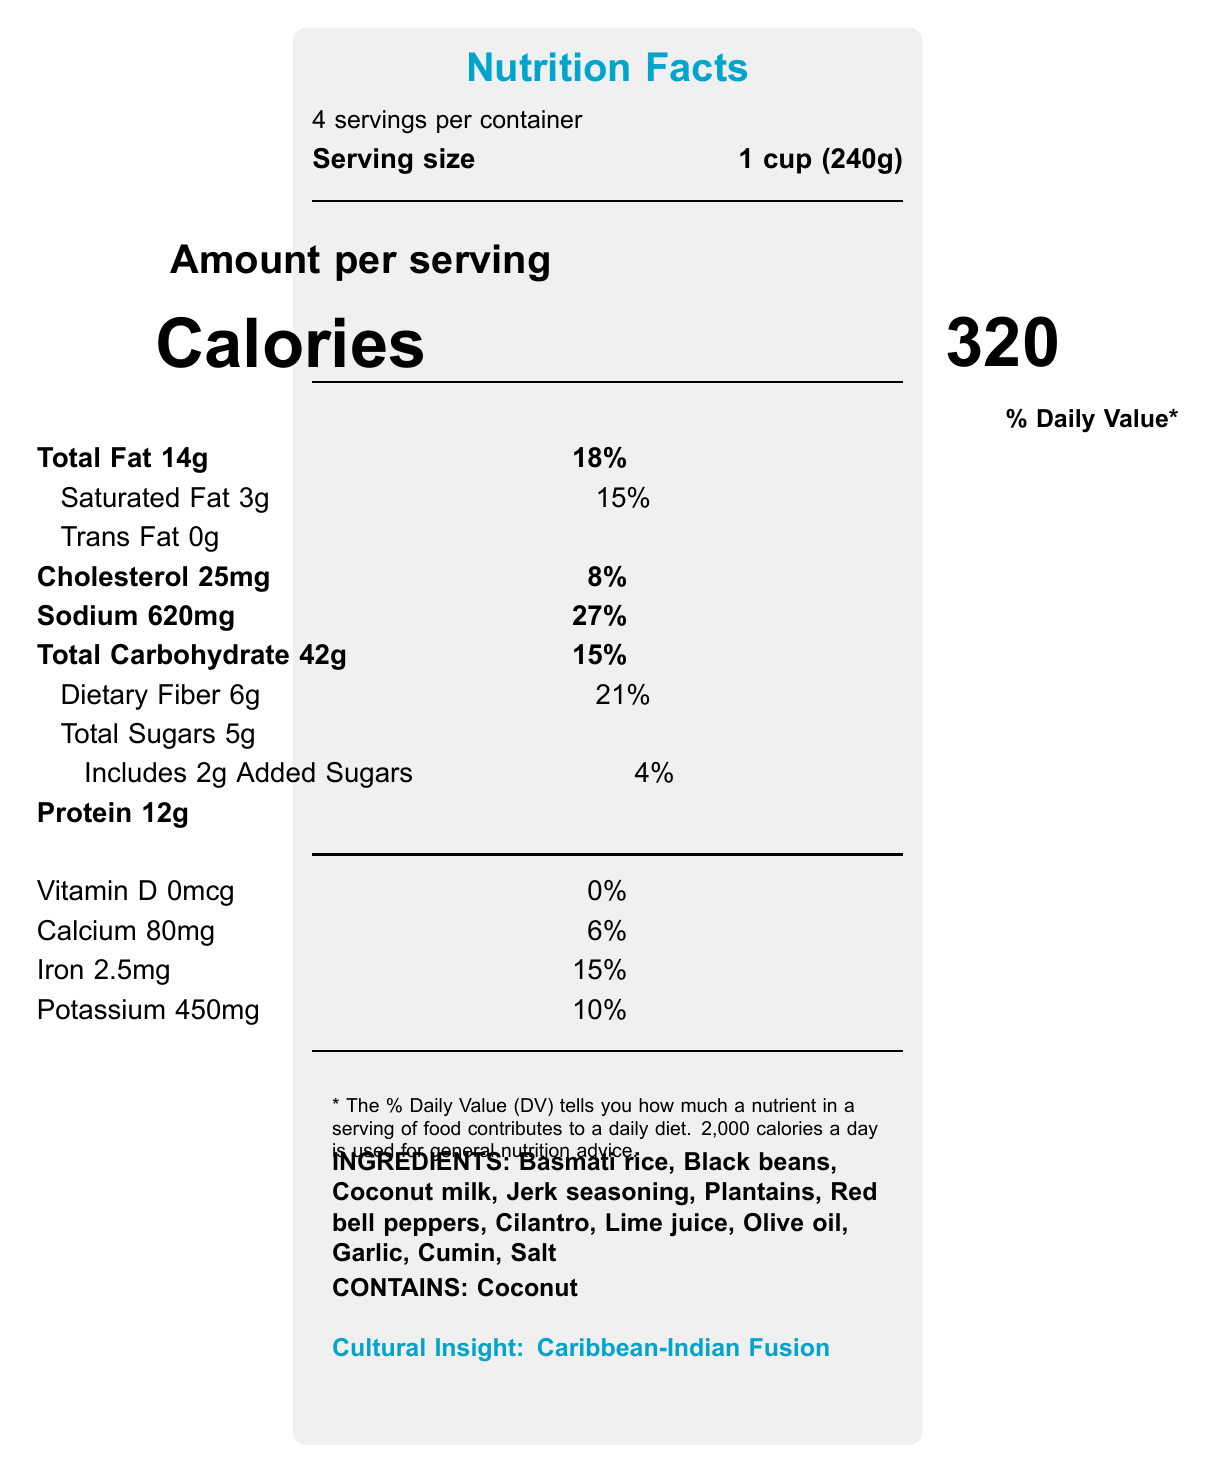What is the serving size? The serving size is clearly stated at the beginning of the document.
Answer: 1 cup (240g) How many servings are there per container? The document states there are 4 servings per container.
Answer: 4 What is the calories per serving? The document shows that each serving contains 320 calories.
Answer: 320 How much total fat is in one serving? The total fat content per serving is listed as 14g.
Answer: 14g What percentage of the daily value of sodium does one serving provide? The document lists that one serving contains 27% of the daily value for sodium.
Answer: 27% Which ingredient in the dish represents Indian influence? According to the cultural insights, basmati rice is indicative of Indian influence.
Answer: Basmati rice Which of the following is an allergen in this dish? A. Milk B. Coconut C. Soy The document lists coconut as an allergen.
Answer: B. Coconut What does the dietary fiber content per serving support? A. Heart health B. Digestive health C. Bone health The nutritional highlights mention that the high fiber content from beans and plantains supports digestive health.
Answer: B. Digestive health Is the protein source plant-based? The document notes that the protein source, black beans, is plant-based.
Answer: Yes Describe the main idea of the document. The document contains various elements that collectively describe the nutritional content, cultural symbolism, and individual identity aspects of the dish.
Answer: The document is a Nutrition Facts Label for a fusion cuisine dish that blends elements of Caribbean and Indian cultures. It provides nutritional information, lists ingredients and allergens, and offers cultural and identity insights related to diaspora communities. What is the exact amount of Vitamin D present in a serving? The document lists the Vitamin D content per serving as 0mcg.
Answer: 0mcg Based on the document, can we determine the cooking method used for this dish? The document provides nutritional details, ingredients, and cultural insights but does not specify the cooking method.
Answer: Not enough information What is the spiciness of this dish meant to symbolize? The identity markers section mentions that the spiciness can be adjusted to reflect individual preferences, symbolizing personal identity within a broader cultural context.
Answer: Personal identity within a broader cultural context How many grams of saturated fat are in one serving? The document shows that each serving contains 3g of saturated fat.
Answer: 3g What amount of added sugars does one serving include? The document lists that each serving includes 2g of added sugars.
Answer: 2g How is the presentation of this dish relevant to cultural identity? The identity markers explain that the dish's presentation can reflect traditional or modern elements, symbolizing the balance between maintaining heritage and assimilation in diaspora communities.
Answer: The presentation can incorporate traditional patterns or modern styles, representing the balance between heritage and assimilation. 